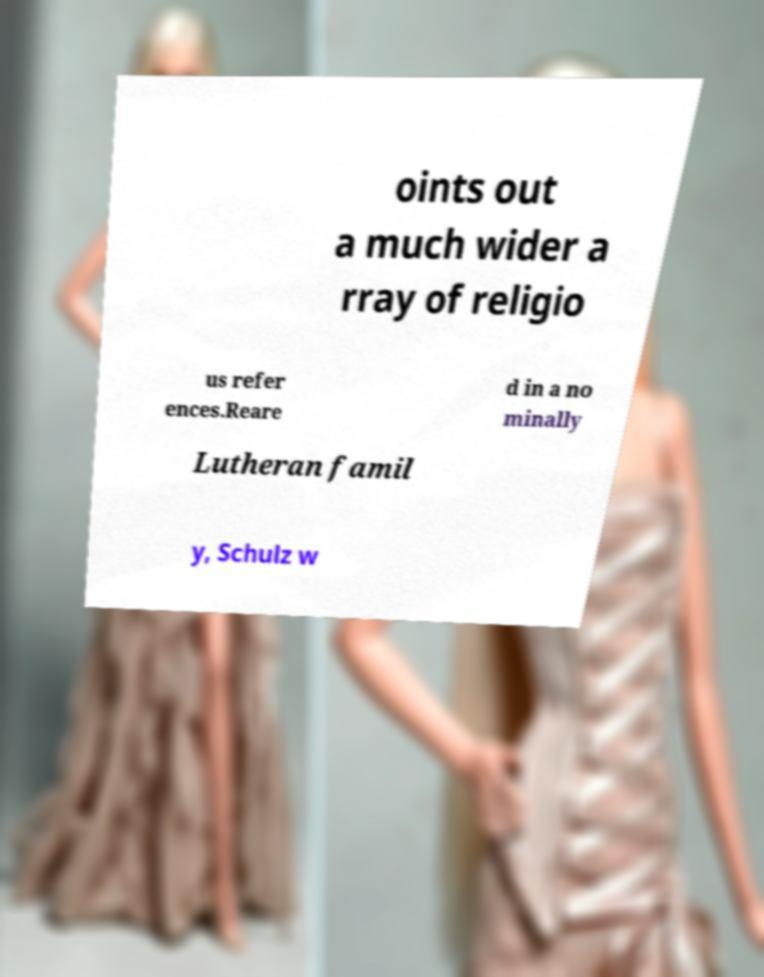What messages or text are displayed in this image? I need them in a readable, typed format. oints out a much wider a rray of religio us refer ences.Reare d in a no minally Lutheran famil y, Schulz w 